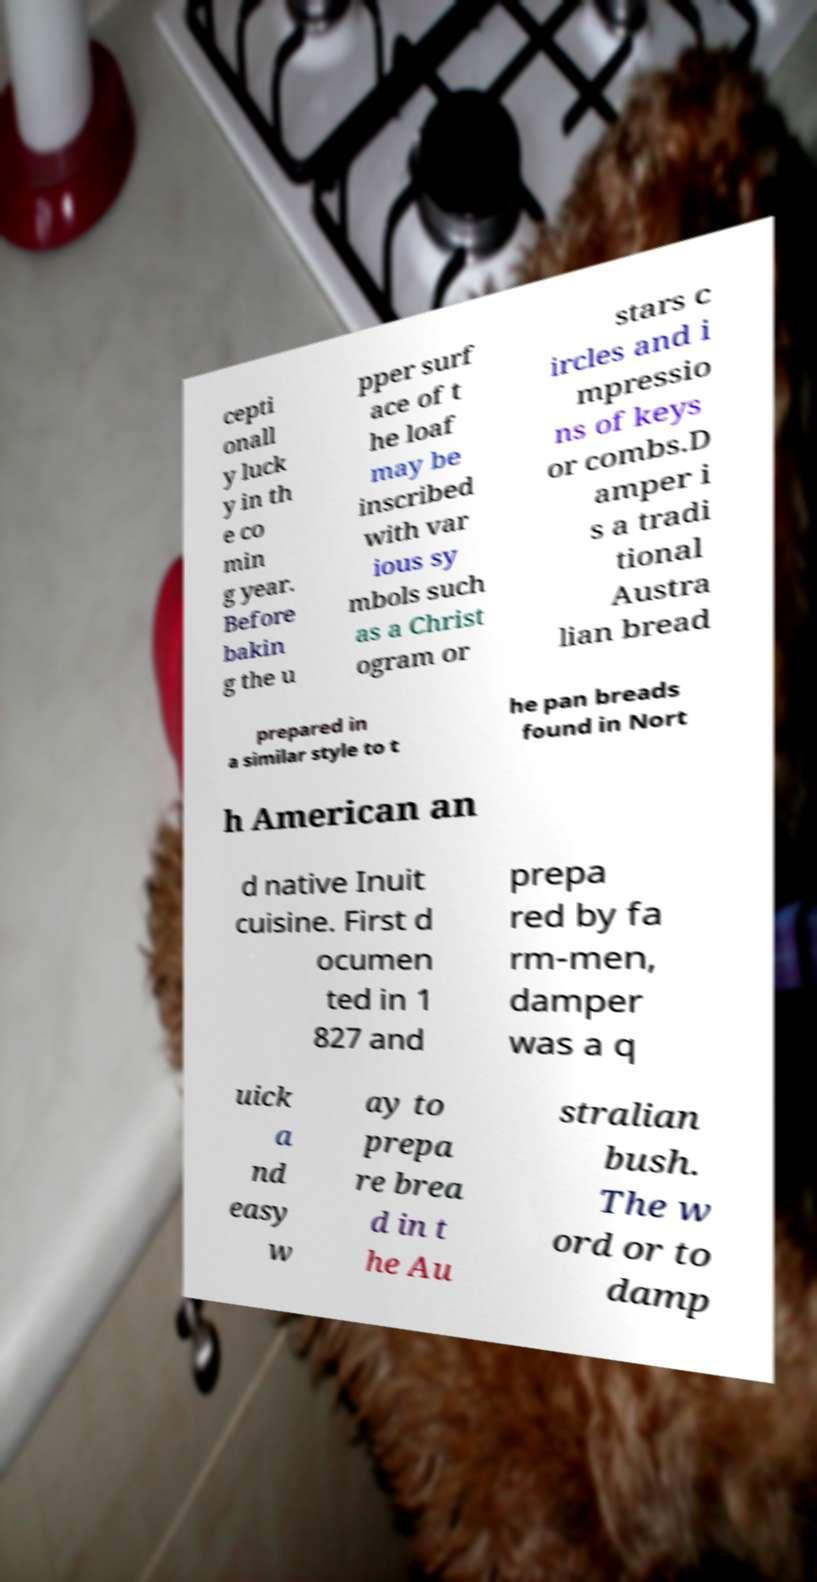Can you accurately transcribe the text from the provided image for me? cepti onall y luck y in th e co min g year. Before bakin g the u pper surf ace of t he loaf may be inscribed with var ious sy mbols such as a Christ ogram or stars c ircles and i mpressio ns of keys or combs.D amper i s a tradi tional Austra lian bread prepared in a similar style to t he pan breads found in Nort h American an d native Inuit cuisine. First d ocumen ted in 1 827 and prepa red by fa rm-men, damper was a q uick a nd easy w ay to prepa re brea d in t he Au stralian bush. The w ord or to damp 